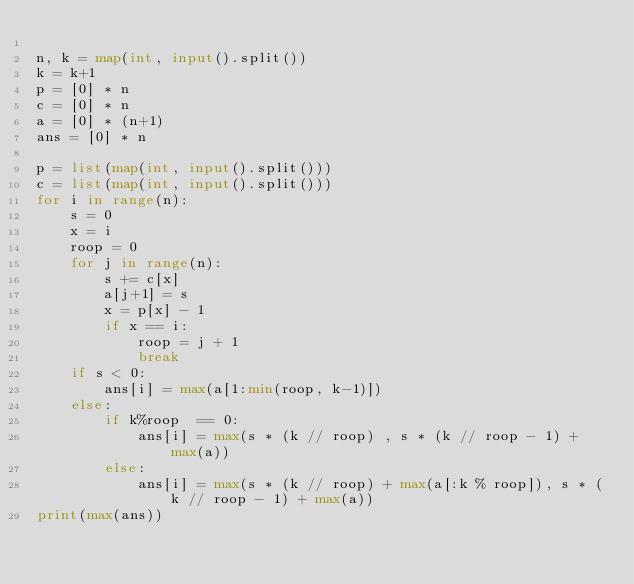<code> <loc_0><loc_0><loc_500><loc_500><_Python_>
n, k = map(int, input().split())
k = k+1
p = [0] * n
c = [0] * n
a = [0] * (n+1)
ans = [0] * n

p = list(map(int, input().split()))
c = list(map(int, input().split()))
for i in range(n):
    s = 0
    x = i
    roop = 0
    for j in range(n):
        s += c[x]
        a[j+1] = s
        x = p[x] - 1
        if x == i:
            roop = j + 1
            break
    if s < 0:
        ans[i] = max(a[1:min(roop, k-1)])
    else:
        if k%roop  == 0:
            ans[i] = max(s * (k // roop) , s * (k // roop - 1) + max(a))
        else:
            ans[i] = max(s * (k // roop) + max(a[:k % roop]), s * (k // roop - 1) + max(a))
print(max(ans))</code> 